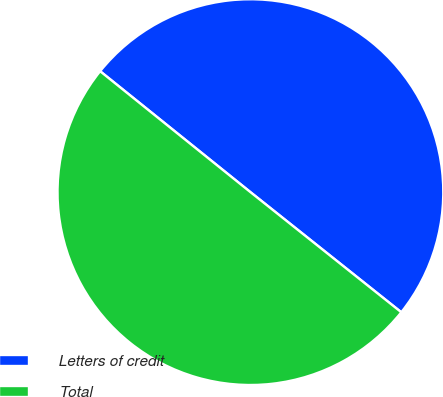Convert chart. <chart><loc_0><loc_0><loc_500><loc_500><pie_chart><fcel>Letters of credit<fcel>Total<nl><fcel>49.92%<fcel>50.08%<nl></chart> 